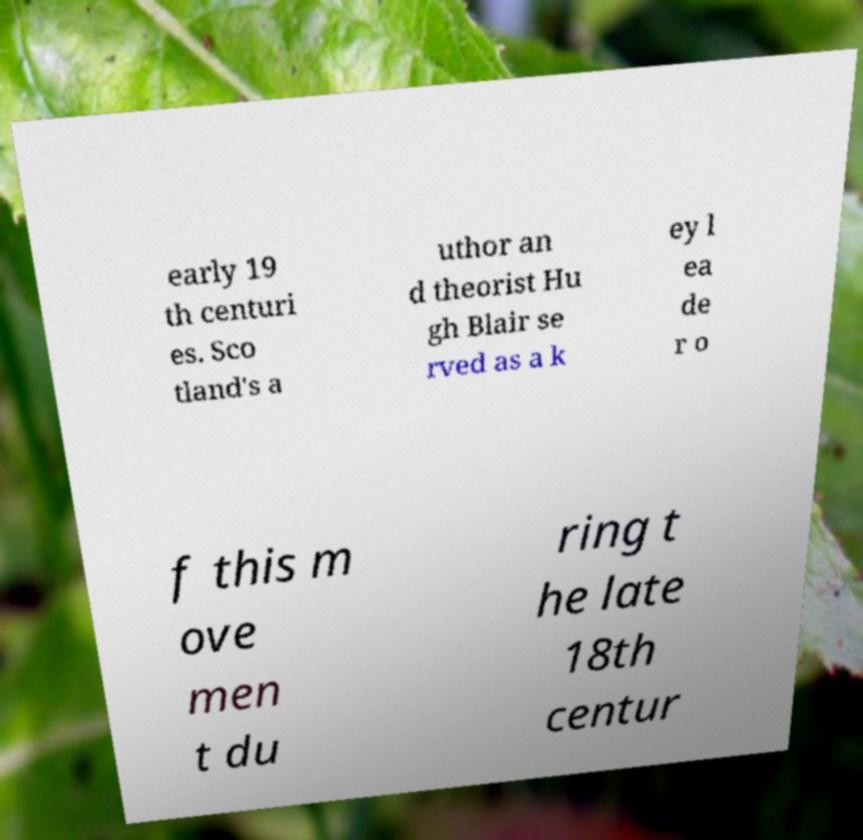Please identify and transcribe the text found in this image. early 19 th centuri es. Sco tland's a uthor an d theorist Hu gh Blair se rved as a k ey l ea de r o f this m ove men t du ring t he late 18th centur 